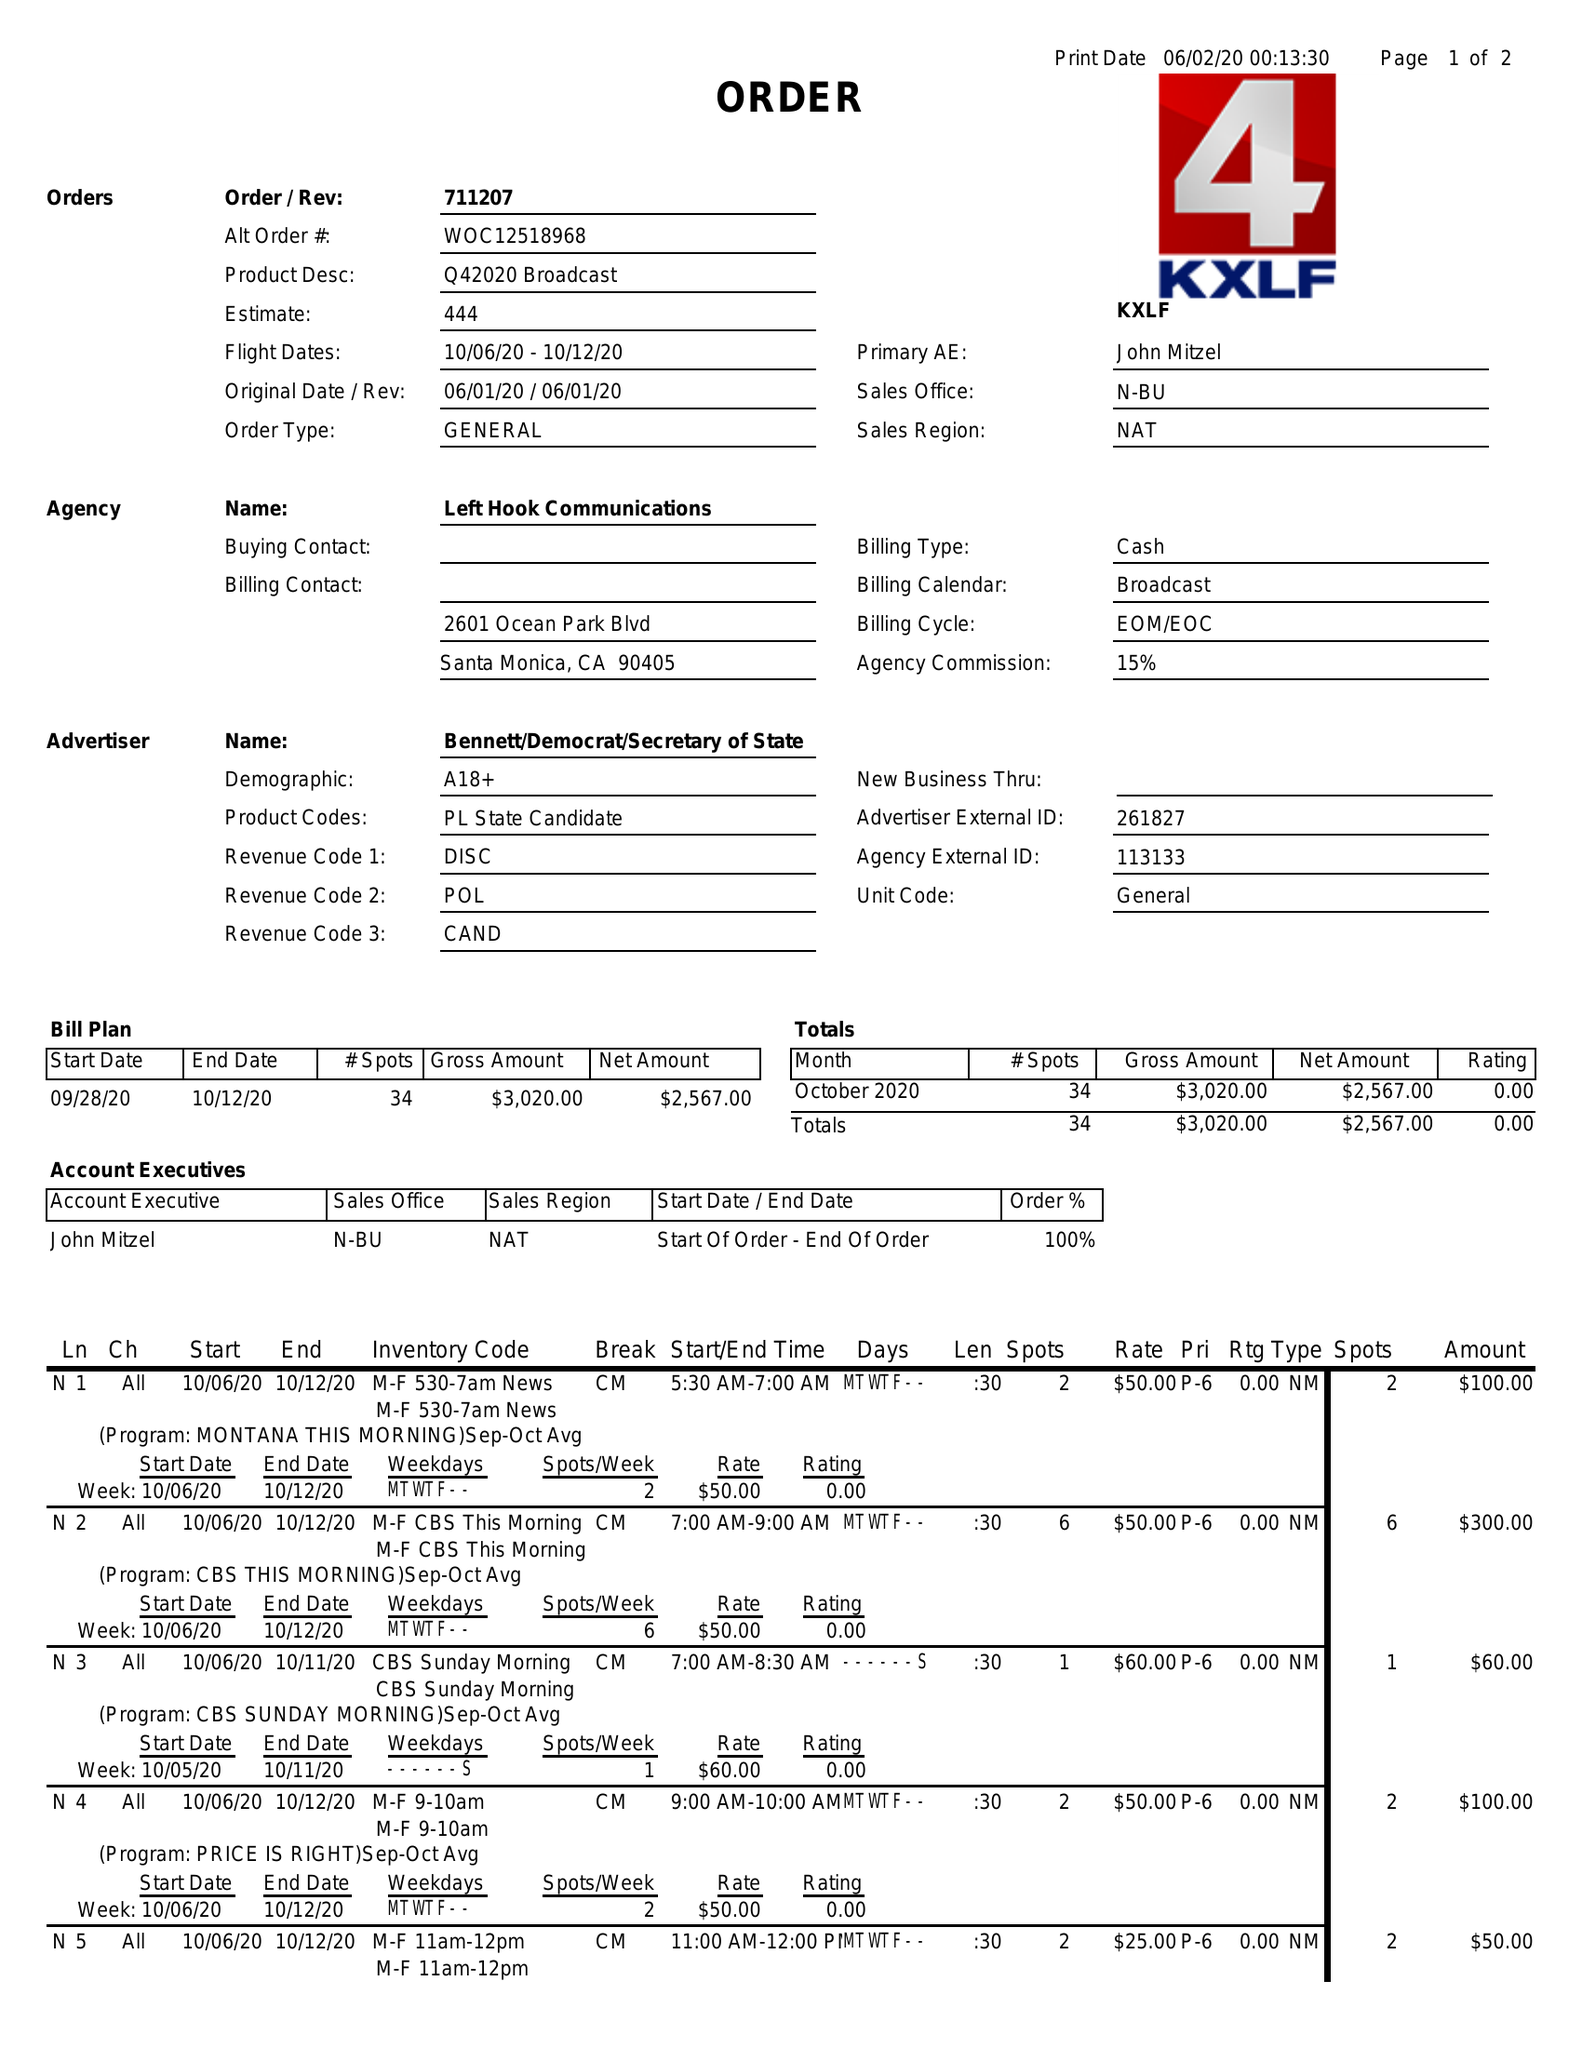What is the value for the contract_num?
Answer the question using a single word or phrase. 711207 